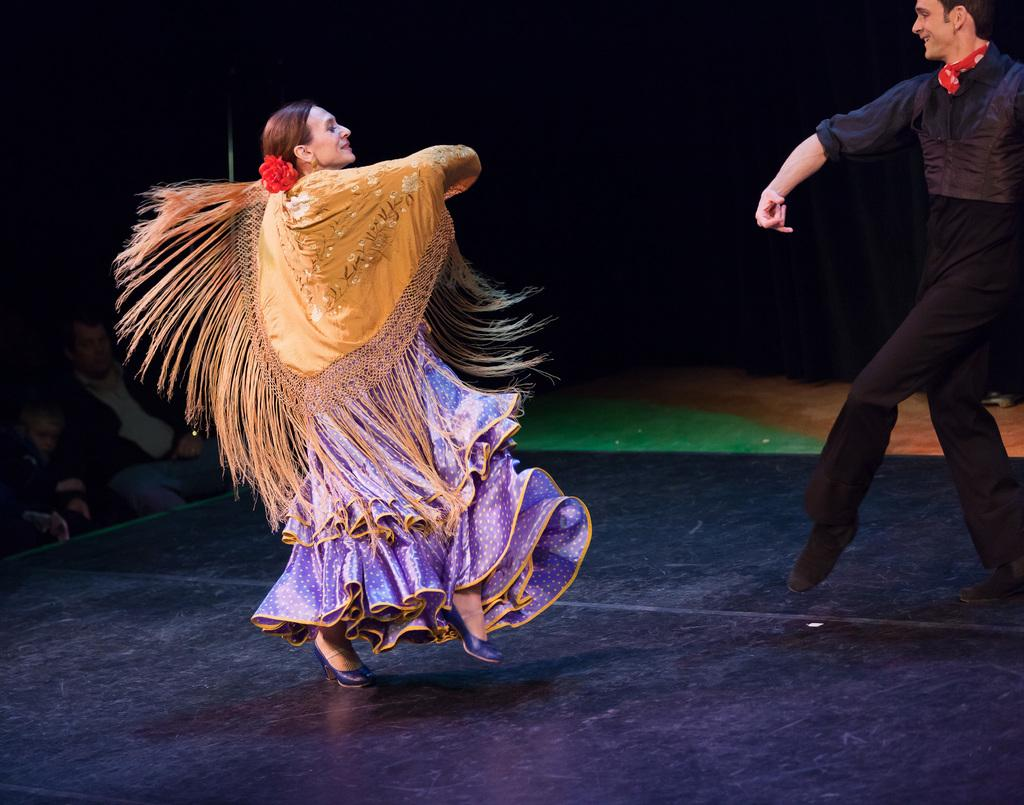Who is present in the image? There is a man and a woman in the image. What are the man and woman doing in the image? The man and woman are dancing. What color is the floor in the image? The floor is black. How would you describe the lighting in the image? The background of the image is dark. Can you see a cactus in the image? No, there is no cactus present in the image. What part of the operation is being performed in the image? There is no operation or any medical procedure being performed in the image; it features a man and a woman dancing. 